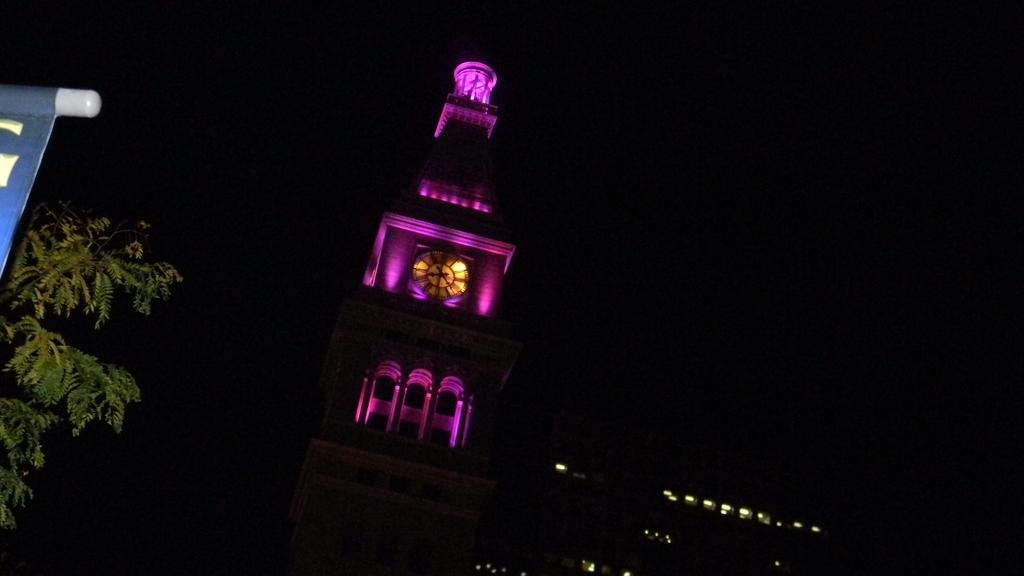What is the main structure in the image? There is a clock tower in the image. What is the primary object in the middle of the image? There is a clock in the middle of the image. What type of vegetation is on the left side of the image? There is a tree on the left side of the image. How would you describe the overall lighting in the image? The background of the image appears to be dark. Can you see the mother holding the baby near the jar in the image? There is no mother, baby, or jar present in the image. 